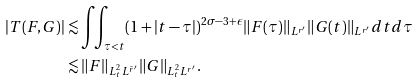Convert formula to latex. <formula><loc_0><loc_0><loc_500><loc_500>| T ( F , G ) | & \lesssim \iint _ { \tau < t } ( 1 + | t - \tau | ) ^ { 2 \sigma - 3 + \epsilon } \| F ( \tau ) \| _ { L ^ { r ^ { \prime } } } \| G ( t ) \| _ { L ^ { r ^ { \prime } } } d t d \tau \\ & \lesssim \| F \| _ { L ^ { 2 } _ { t } L ^ { \tilde { r } ^ { \prime } } } \| G \| _ { L ^ { 2 } _ { t } L ^ { r ^ { \prime } } } .</formula> 